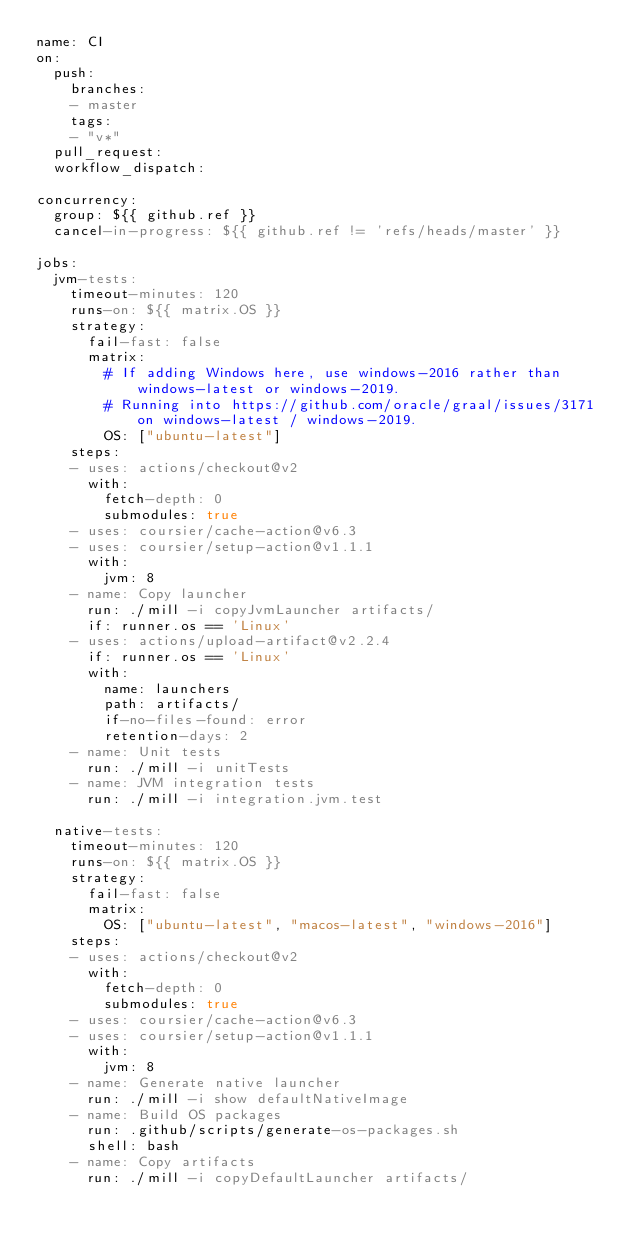Convert code to text. <code><loc_0><loc_0><loc_500><loc_500><_YAML_>name: CI
on:
  push:
    branches:
    - master
    tags:
    - "v*"
  pull_request:
  workflow_dispatch:

concurrency:
  group: ${{ github.ref }}
  cancel-in-progress: ${{ github.ref != 'refs/heads/master' }}

jobs:
  jvm-tests:
    timeout-minutes: 120
    runs-on: ${{ matrix.OS }}
    strategy:
      fail-fast: false
      matrix:
        # If adding Windows here, use windows-2016 rather than windows-latest or windows-2019.
        # Running into https://github.com/oracle/graal/issues/3171 on windows-latest / windows-2019.
        OS: ["ubuntu-latest"]
    steps:
    - uses: actions/checkout@v2
      with:
        fetch-depth: 0
        submodules: true
    - uses: coursier/cache-action@v6.3
    - uses: coursier/setup-action@v1.1.1
      with:
        jvm: 8
    - name: Copy launcher
      run: ./mill -i copyJvmLauncher artifacts/
      if: runner.os == 'Linux'
    - uses: actions/upload-artifact@v2.2.4
      if: runner.os == 'Linux'
      with:
        name: launchers
        path: artifacts/
        if-no-files-found: error
        retention-days: 2
    - name: Unit tests
      run: ./mill -i unitTests
    - name: JVM integration tests
      run: ./mill -i integration.jvm.test

  native-tests:
    timeout-minutes: 120
    runs-on: ${{ matrix.OS }}
    strategy:
      fail-fast: false
      matrix:
        OS: ["ubuntu-latest", "macos-latest", "windows-2016"]
    steps:
    - uses: actions/checkout@v2
      with:
        fetch-depth: 0
        submodules: true
    - uses: coursier/cache-action@v6.3
    - uses: coursier/setup-action@v1.1.1
      with:
        jvm: 8
    - name: Generate native launcher
      run: ./mill -i show defaultNativeImage
    - name: Build OS packages
      run: .github/scripts/generate-os-packages.sh
      shell: bash
    - name: Copy artifacts
      run: ./mill -i copyDefaultLauncher artifacts/</code> 